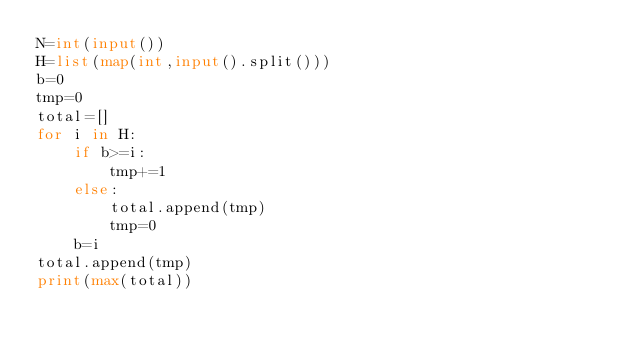<code> <loc_0><loc_0><loc_500><loc_500><_Python_>N=int(input())
H=list(map(int,input().split()))
b=0
tmp=0
total=[]
for i in H:
    if b>=i:
        tmp+=1
    else:
        total.append(tmp)
        tmp=0
    b=i
total.append(tmp)
print(max(total))</code> 